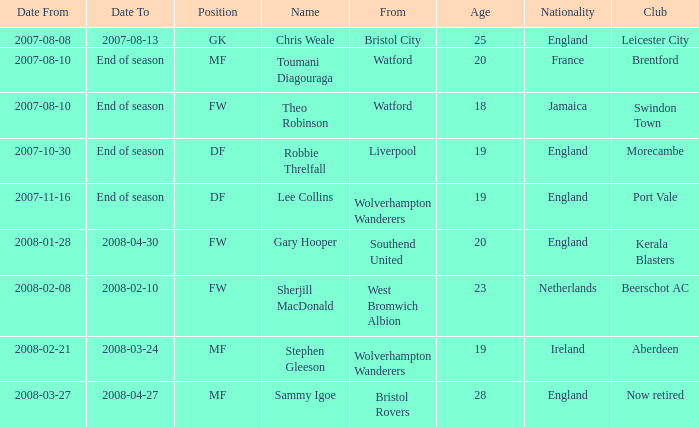What was the from for the Date From of 2007-08-08? Bristol City. 